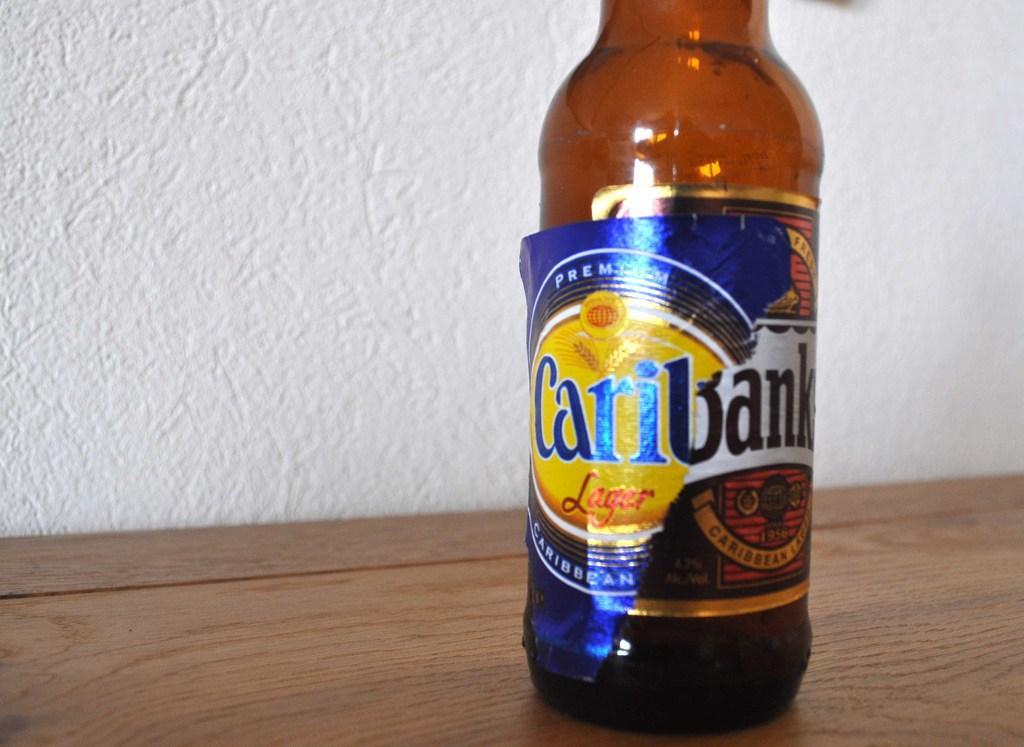Please provide a concise description of this image. This picture contain an alcohol bottle which is placed on a table. On the bottle, it is written as 'Cary Bank'. Behind the bottle, we see a white wall. 